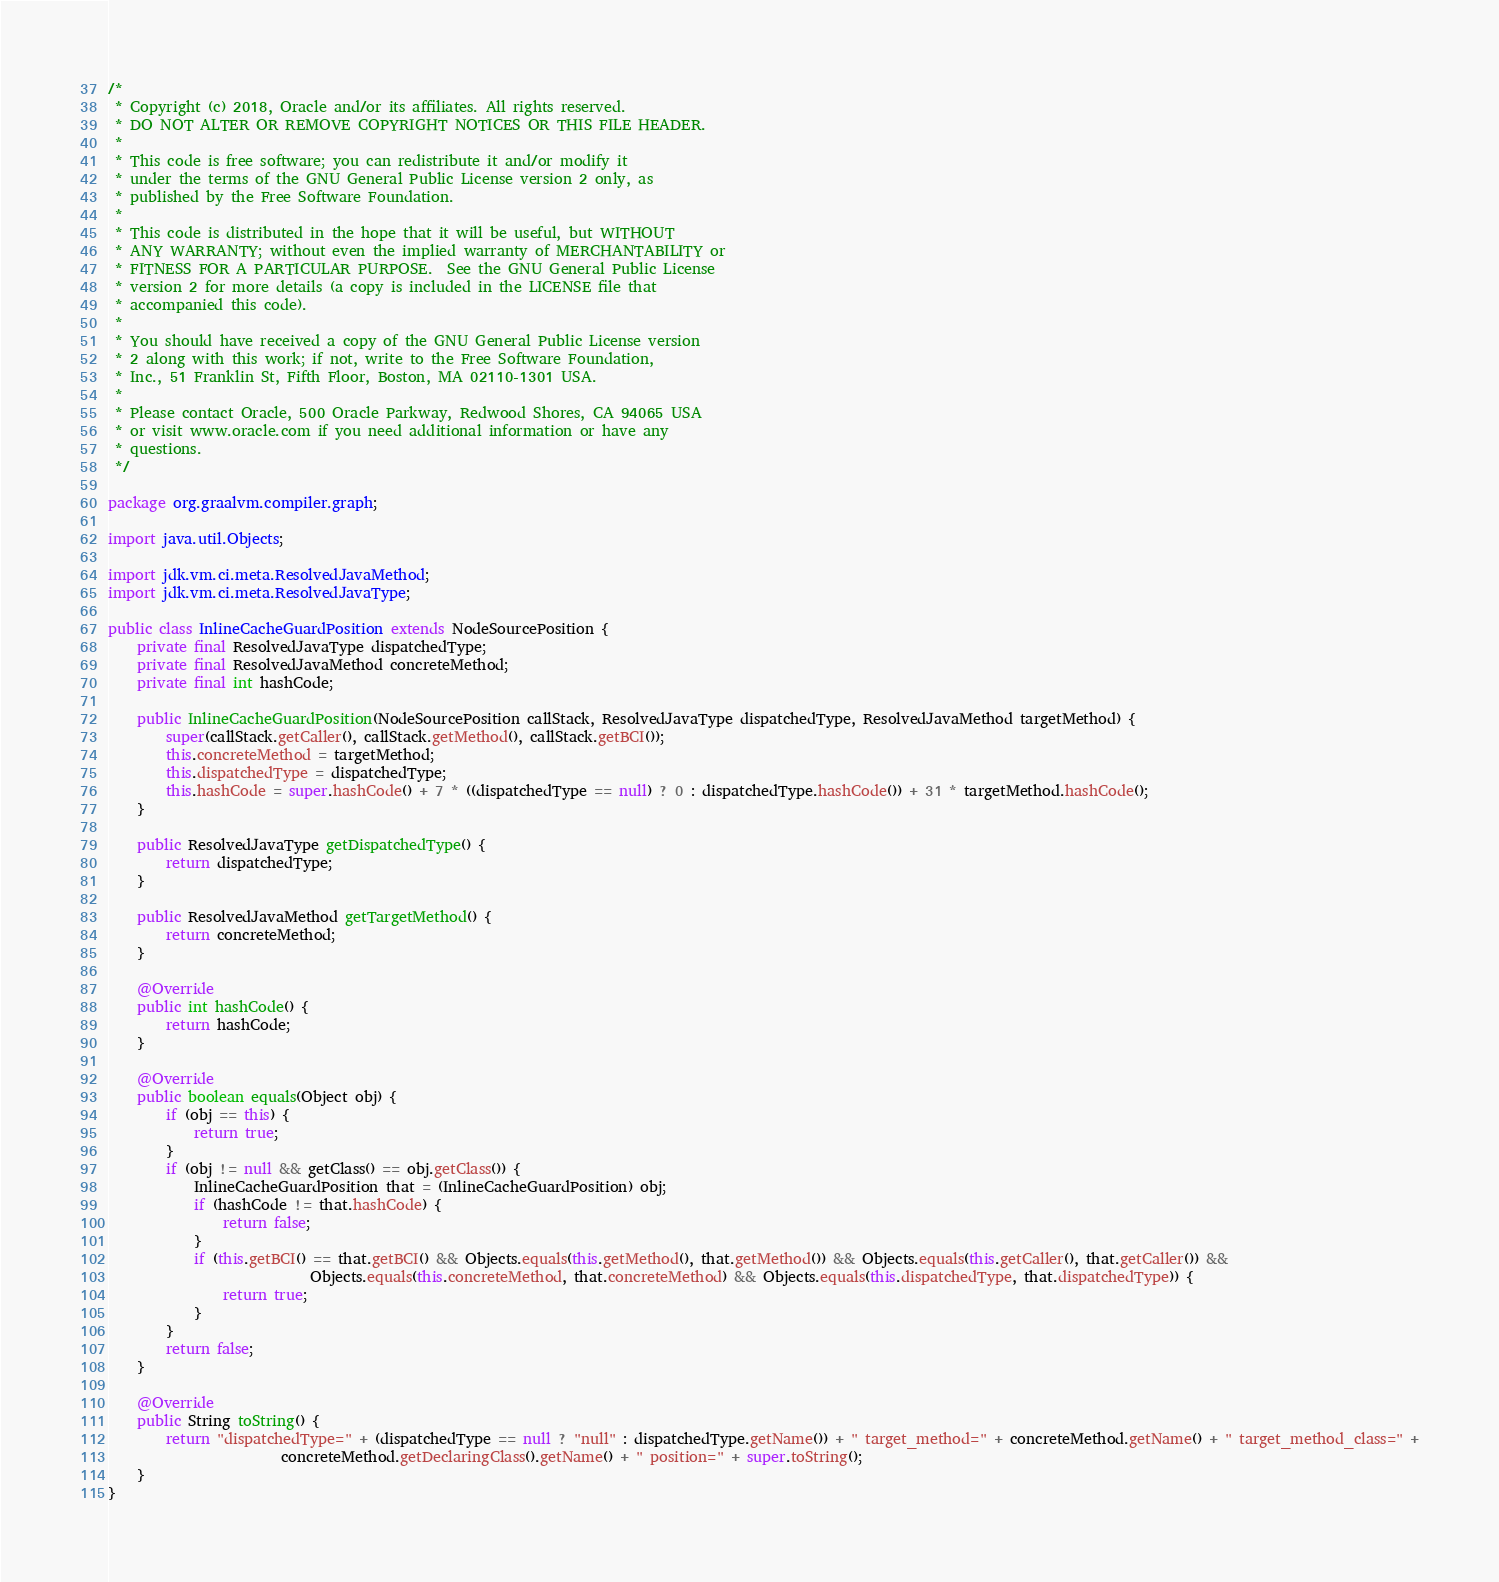<code> <loc_0><loc_0><loc_500><loc_500><_Java_>/*
 * Copyright (c) 2018, Oracle and/or its affiliates. All rights reserved.
 * DO NOT ALTER OR REMOVE COPYRIGHT NOTICES OR THIS FILE HEADER.
 *
 * This code is free software; you can redistribute it and/or modify it
 * under the terms of the GNU General Public License version 2 only, as
 * published by the Free Software Foundation.
 *
 * This code is distributed in the hope that it will be useful, but WITHOUT
 * ANY WARRANTY; without even the implied warranty of MERCHANTABILITY or
 * FITNESS FOR A PARTICULAR PURPOSE.  See the GNU General Public License
 * version 2 for more details (a copy is included in the LICENSE file that
 * accompanied this code).
 *
 * You should have received a copy of the GNU General Public License version
 * 2 along with this work; if not, write to the Free Software Foundation,
 * Inc., 51 Franklin St, Fifth Floor, Boston, MA 02110-1301 USA.
 *
 * Please contact Oracle, 500 Oracle Parkway, Redwood Shores, CA 94065 USA
 * or visit www.oracle.com if you need additional information or have any
 * questions.
 */

package org.graalvm.compiler.graph;

import java.util.Objects;

import jdk.vm.ci.meta.ResolvedJavaMethod;
import jdk.vm.ci.meta.ResolvedJavaType;

public class InlineCacheGuardPosition extends NodeSourcePosition {
    private final ResolvedJavaType dispatchedType;
    private final ResolvedJavaMethod concreteMethod;
    private final int hashCode;

    public InlineCacheGuardPosition(NodeSourcePosition callStack, ResolvedJavaType dispatchedType, ResolvedJavaMethod targetMethod) {
        super(callStack.getCaller(), callStack.getMethod(), callStack.getBCI());
        this.concreteMethod = targetMethod;
        this.dispatchedType = dispatchedType;
        this.hashCode = super.hashCode() + 7 * ((dispatchedType == null) ? 0 : dispatchedType.hashCode()) + 31 * targetMethod.hashCode();
    }

    public ResolvedJavaType getDispatchedType() {
        return dispatchedType;
    }

    public ResolvedJavaMethod getTargetMethod() {
        return concreteMethod;
    }

    @Override
    public int hashCode() {
        return hashCode;
    }

    @Override
    public boolean equals(Object obj) {
        if (obj == this) {
            return true;
        }
        if (obj != null && getClass() == obj.getClass()) {
            InlineCacheGuardPosition that = (InlineCacheGuardPosition) obj;
            if (hashCode != that.hashCode) {
                return false;
            }
            if (this.getBCI() == that.getBCI() && Objects.equals(this.getMethod(), that.getMethod()) && Objects.equals(this.getCaller(), that.getCaller()) &&
                            Objects.equals(this.concreteMethod, that.concreteMethod) && Objects.equals(this.dispatchedType, that.dispatchedType)) {
                return true;
            }
        }
        return false;
    }

    @Override
    public String toString() {
        return "dispatchedType=" + (dispatchedType == null ? "null" : dispatchedType.getName()) + " target_method=" + concreteMethod.getName() + " target_method_class=" +
                        concreteMethod.getDeclaringClass().getName() + " position=" + super.toString();
    }
}
</code> 